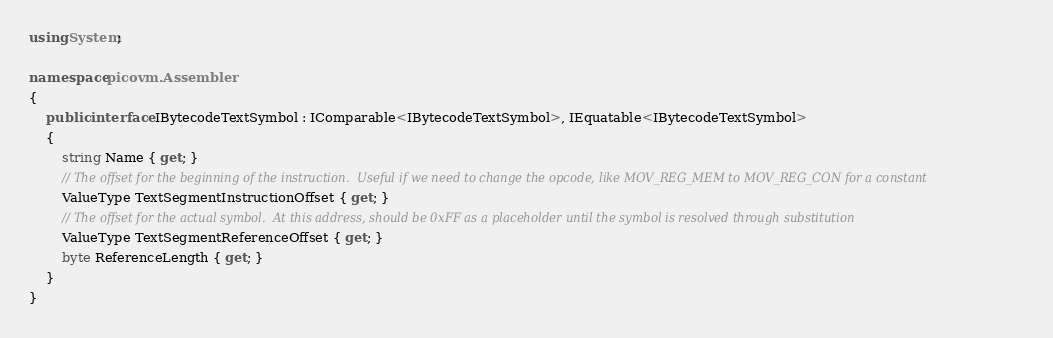Convert code to text. <code><loc_0><loc_0><loc_500><loc_500><_C#_>using System;

namespace picovm.Assembler
{
    public interface IBytecodeTextSymbol : IComparable<IBytecodeTextSymbol>, IEquatable<IBytecodeTextSymbol>
    {
        string Name { get; }
        // The offset for the beginning of the instruction.  Useful if we need to change the opcode, like MOV_REG_MEM to MOV_REG_CON for a constant
        ValueType TextSegmentInstructionOffset { get; }
        // The offset for the actual symbol.  At this address, should be 0xFF as a placeholder until the symbol is resolved through substitution
        ValueType TextSegmentReferenceOffset { get; }
        byte ReferenceLength { get; }
    }
}</code> 